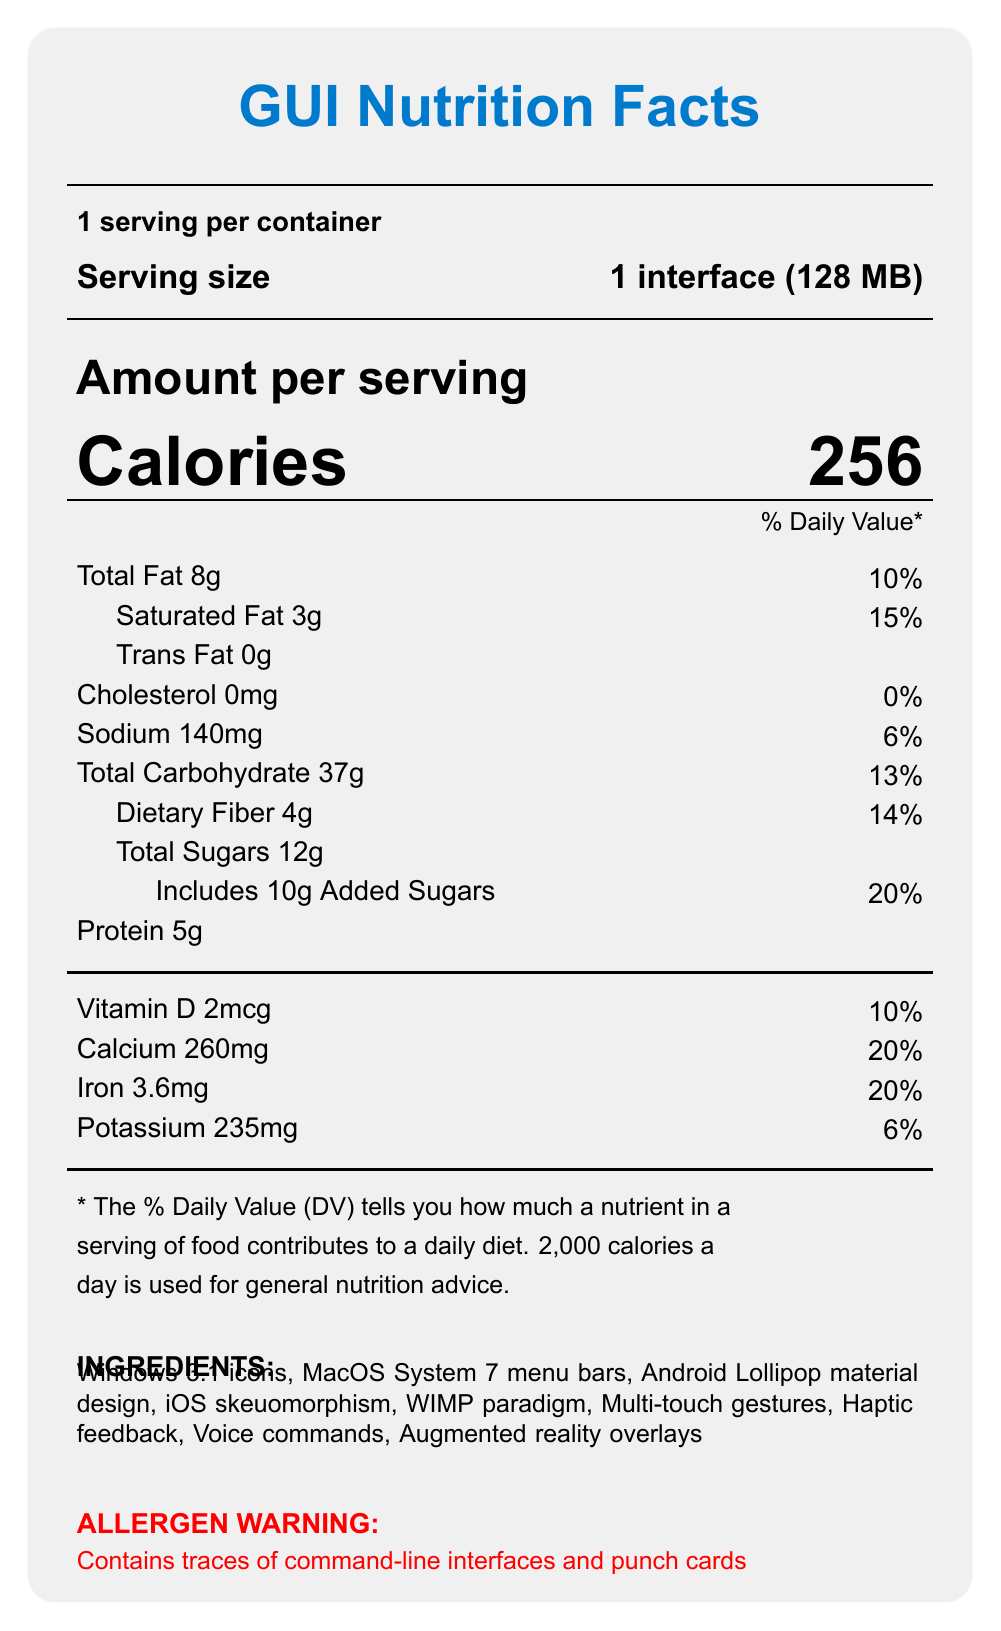what is the serving size? The document states that the serving size is "1 interface (128 MB)".
Answer: 1 interface (128 MB) how many calories are in one serving? The document lists the number of calories per serving as 256.
Answer: 256 how much saturated fat is in each serving? The document states that each serving contains 3g of saturated fat.
Answer: 3g Are there any trans fats in the product? The document specifies that the amount of trans fat per serving is 0g.
Answer: No what is the percentage of daily value for dietary fiber? The document shows that the daily value percentage for dietary fiber is 14%.
Answer: 14% which ingredient is not included in the product? A. Voice commands B. Multi-touch gestures C. Mouse pointer D. Augmented reality overlays The ingredient list includes Voice commands, Multi-touch gestures, and Augmented reality overlays, but not Mouse pointer.
Answer: C which comparison is given for productivity enhancement? I. classic GUI: 85%, modern touchscreen: 80% II. classic GUI: 80%, modern touchscreen: 85% III. classic GUI: 90%, modern touchscreen: 75% The document states that productivity enhancement is 85% for classic GUI and 80% for modern touchscreen.
Answer: I Does the product contain any punch cards? The document mentions an allergen warning that the product contains traces of punch cards.
Answer: Yes Summarize the main idea of the document. The "GUI Nutrition Facts" label provides a comparison of nutritional values, benefits, and other relevant details of classic GUI and modern touchscreen interfaces. It includes breakdowns of various components and offers a comparative analysis in a structured format.
Answer: The document is a "GUI Nutrition Facts" label comparing the nutritional values and benefits of classic GUI operating systems and modern touchscreen interfaces. It includes detailed information on calories, fats, cholesterol, sodium, carbohydrate, protein, and vitamins, as well as a comparison of user friendliness, learning curve, and productivity enhancement. What is the total amount of added sugars in the product? The document specifies that there are 10g of added sugars included in the total sugars.
Answer: 10g how much iron is in one serving? The document lists the amount of iron per serving as 3.6mg.
Answer: 3.6mg Which of these daily values is higher? A. Sodium B. Calcium The daily value for sodium is 6%, whereas the daily value for calcium is 20%.
Answer: B What are the classic GUI benefits mentioned in the document? The document lists three benefits for classic GUI: rich in WIMP nutrients, high in pixel-perfect precision, and good source of keyboard shortcuts.
Answer: Rich in WIMP nutrients, High in pixel-perfect precision, Good source of keyboard shortcuts Can you determine the exact year when MacOS System 7 menu bars were introduced from this document? The document does not provide information on the exact year of introduction for MacOS System 7 menu bars.
Answer: Not enough information 